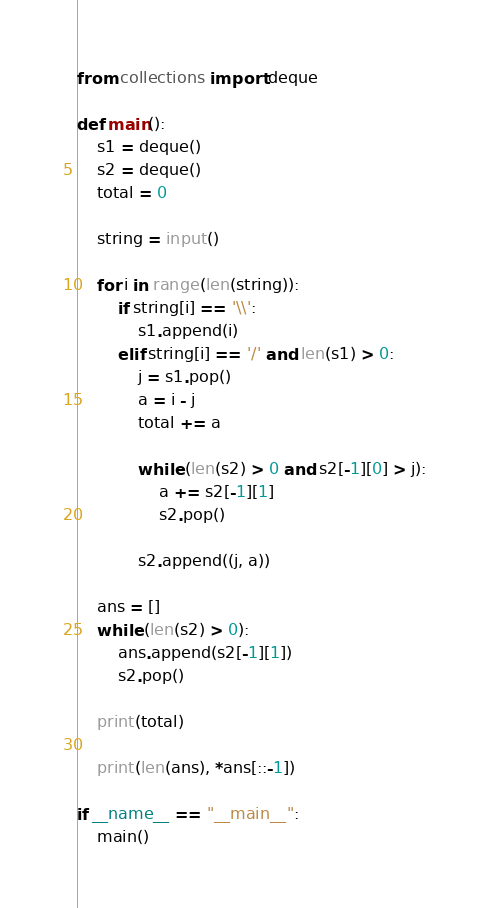Convert code to text. <code><loc_0><loc_0><loc_500><loc_500><_Python_>
from collections import deque

def main():
    s1 = deque()
    s2 = deque()
    total = 0

    string = input()

    for i in range(len(string)):
        if string[i] == '\\':
            s1.append(i)
        elif string[i] == '/' and len(s1) > 0:
            j = s1.pop()
            a = i - j
            total += a

            while (len(s2) > 0 and s2[-1][0] > j):
                a += s2[-1][1]
                s2.pop()

            s2.append((j, a))

    ans = []
    while (len(s2) > 0):
        ans.append(s2[-1][1])
        s2.pop()

    print(total)

    print(len(ans), *ans[::-1])

if __name__ == "__main__":
    main()</code> 